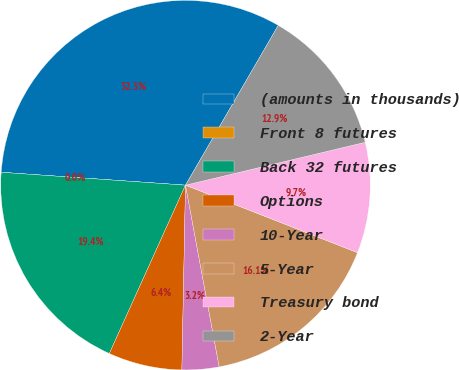Convert chart. <chart><loc_0><loc_0><loc_500><loc_500><pie_chart><fcel>(amounts in thousands)<fcel>Front 8 futures<fcel>Back 32 futures<fcel>Options<fcel>10-Year<fcel>5-Year<fcel>Treasury bond<fcel>2-Year<nl><fcel>32.26%<fcel>0.0%<fcel>19.35%<fcel>6.45%<fcel>3.23%<fcel>16.13%<fcel>9.68%<fcel>12.9%<nl></chart> 